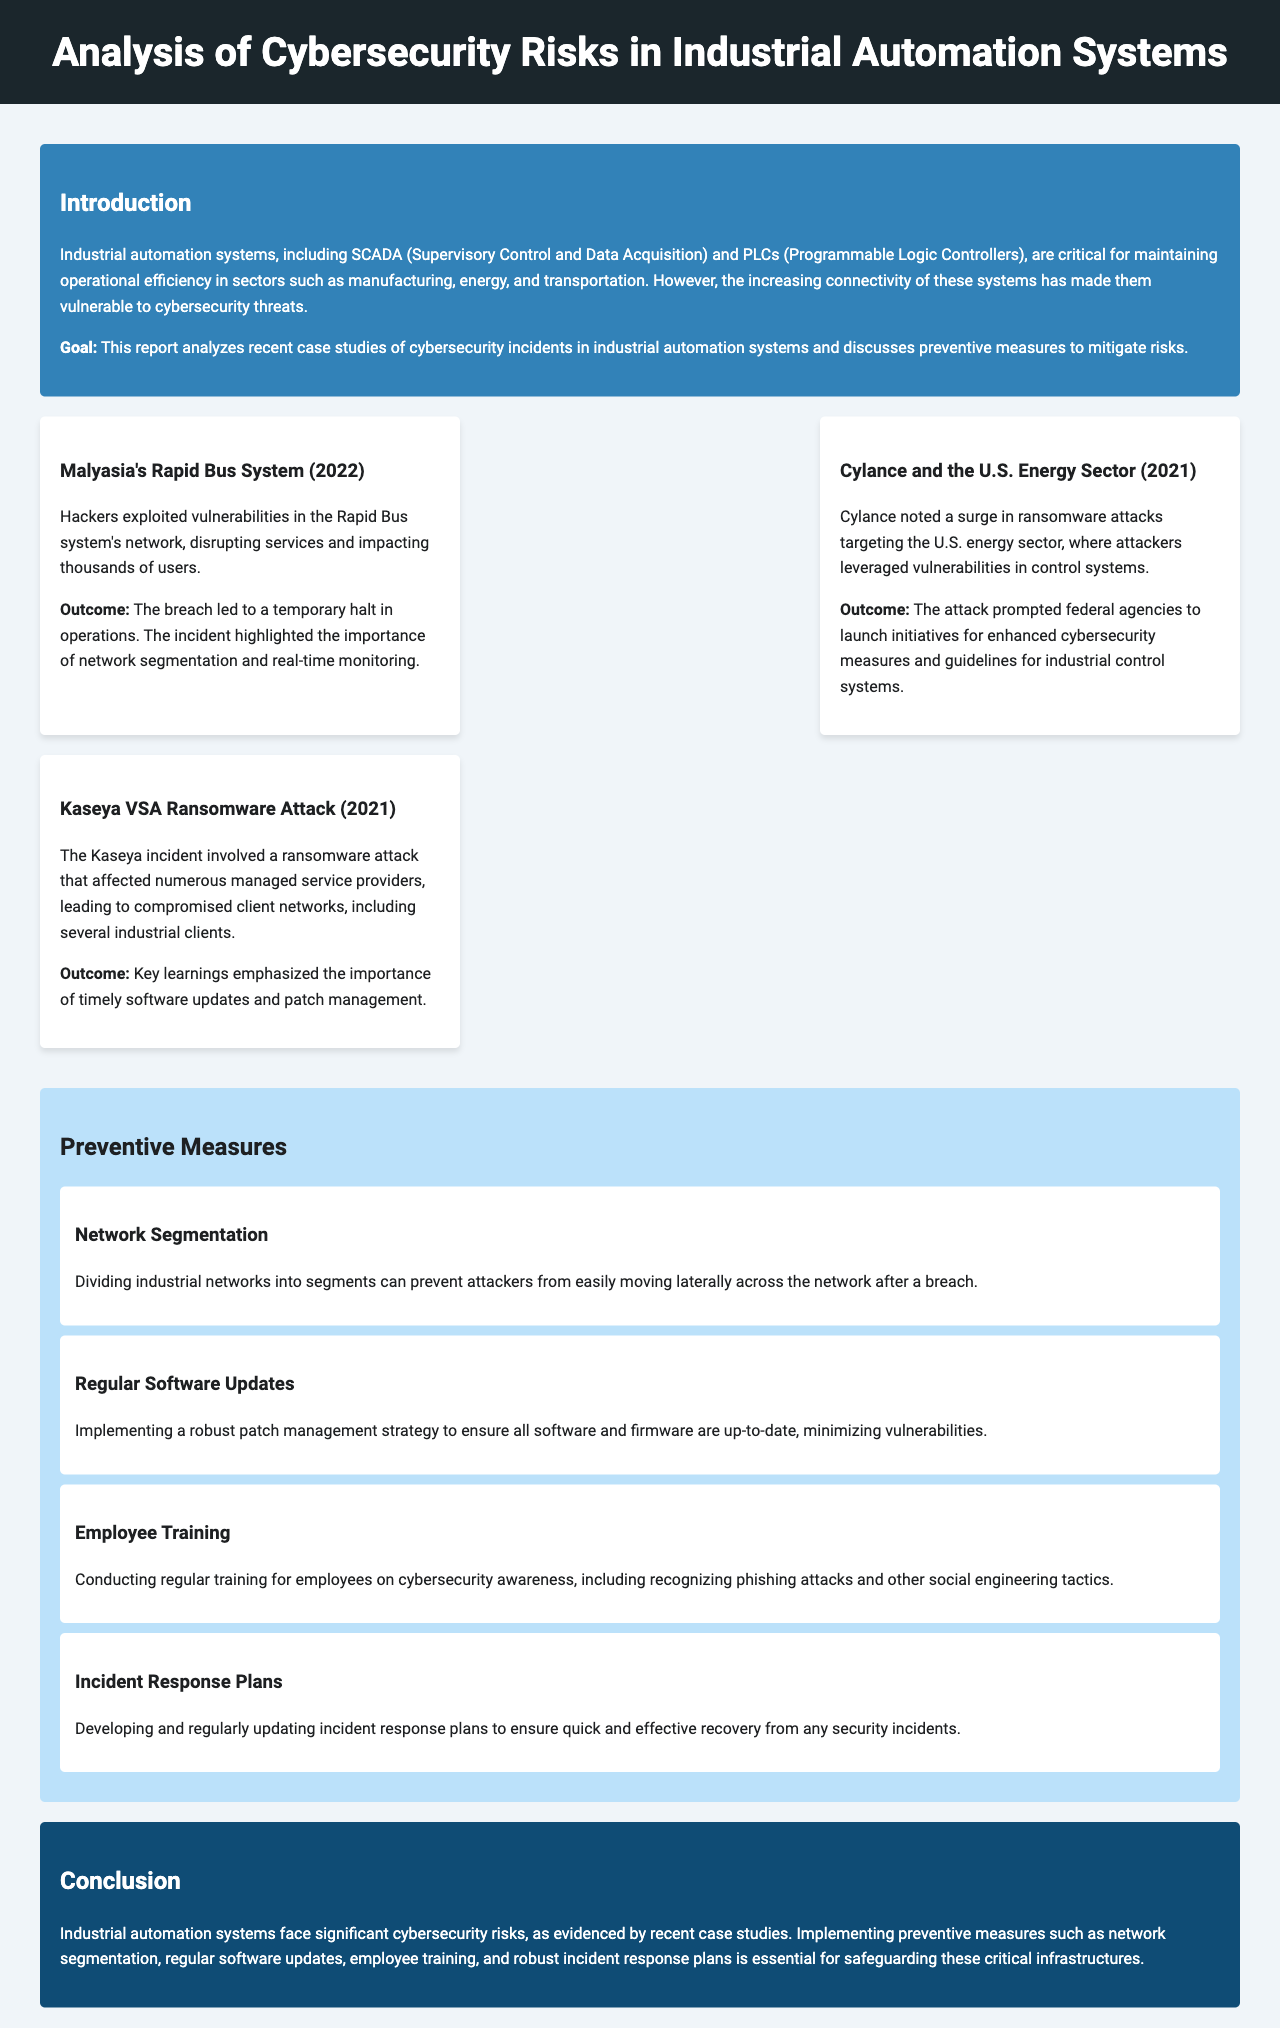What incident occurred in Malaysia’s Rapid Bus System? The incident involved hackers exploiting vulnerabilities in the network, disrupting services and impacting thousands of users.
Answer: Hackers exploited vulnerabilities in the Rapid Bus system's network What was the outcome of the Cylance incident in the U.S. energy sector? The outcome prompted federal agencies to launch initiatives for enhanced cybersecurity measures and guidelines for industrial control systems.
Answer: Enhanced cybersecurity measures and guidelines What year did the Kaseya VSA ransomware attack occur? The document states that the Kaseya incident took place in 2021.
Answer: 2021 What is one preventive measure mentioned in the report? Several preventive measures are listed, including network segmentation and regular software updates.
Answer: Network segmentation How many case studies are presented in the report? The report presents three case studies related to cybersecurity incidents.
Answer: Three case studies What type of systems does the report focus on? The report focuses on industrial automation systems, specifically SCADA and PLCs.
Answer: Industrial automation systems What is the goal of this report? The goal of the report is to analyze recent case studies of cybersecurity incidents and discuss preventive measures.
Answer: Analyze recent case studies and discuss preventive measures What is the background color of the conclusion section? The conclusion section has a dark blue background color.
Answer: Dark blue 